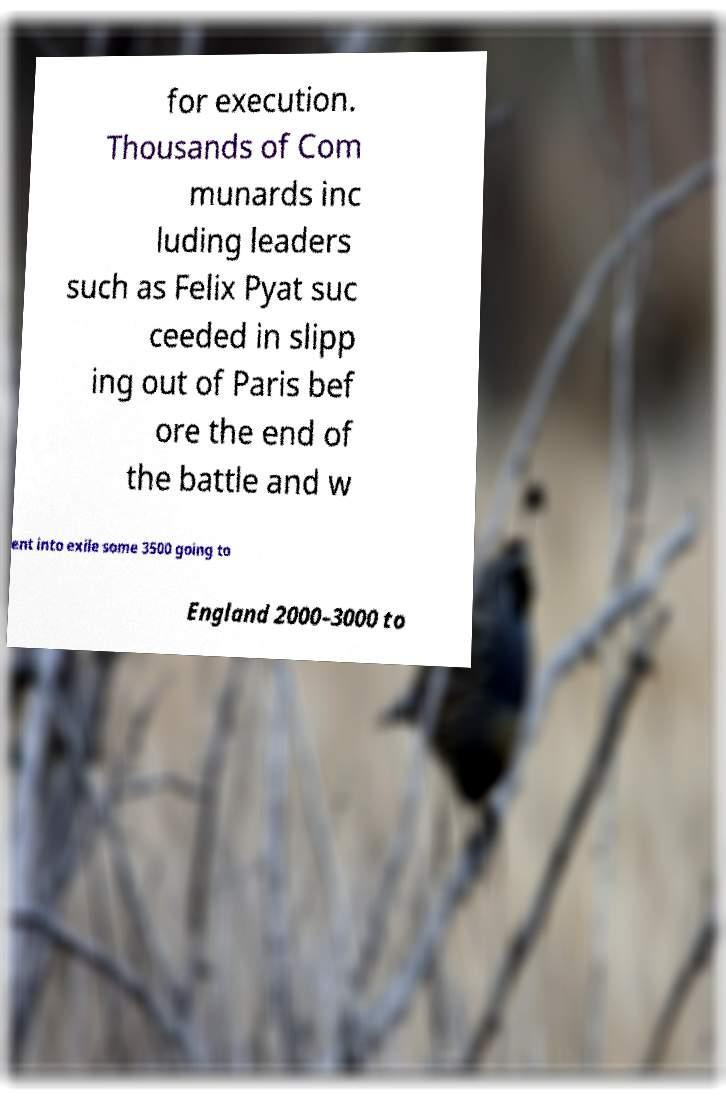Please read and relay the text visible in this image. What does it say? for execution. Thousands of Com munards inc luding leaders such as Felix Pyat suc ceeded in slipp ing out of Paris bef ore the end of the battle and w ent into exile some 3500 going to England 2000–3000 to 